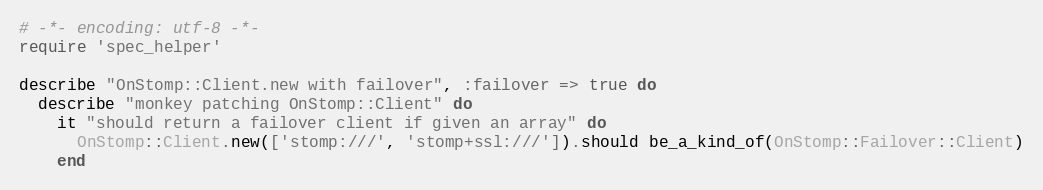Convert code to text. <code><loc_0><loc_0><loc_500><loc_500><_Ruby_># -*- encoding: utf-8 -*-
require 'spec_helper'

describe "OnStomp::Client.new with failover", :failover => true do
  describe "monkey patching OnStomp::Client" do
    it "should return a failover client if given an array" do
      OnStomp::Client.new(['stomp:///', 'stomp+ssl:///']).should be_a_kind_of(OnStomp::Failover::Client)
    end</code> 